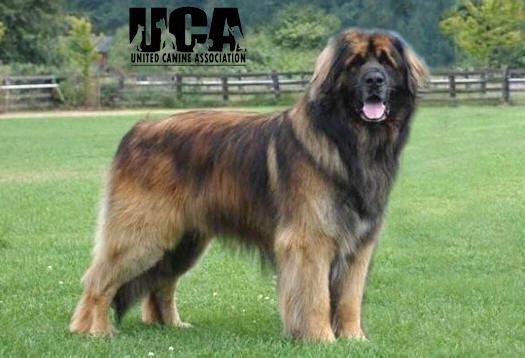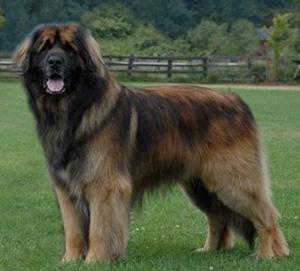The first image is the image on the left, the second image is the image on the right. Assess this claim about the two images: "A dog is being touched by a human in one of the images.". Correct or not? Answer yes or no. No. The first image is the image on the left, the second image is the image on the right. Assess this claim about the two images: "Exactly one of the dogs is shown standing in profile on all fours in the grass.". Correct or not? Answer yes or no. No. 